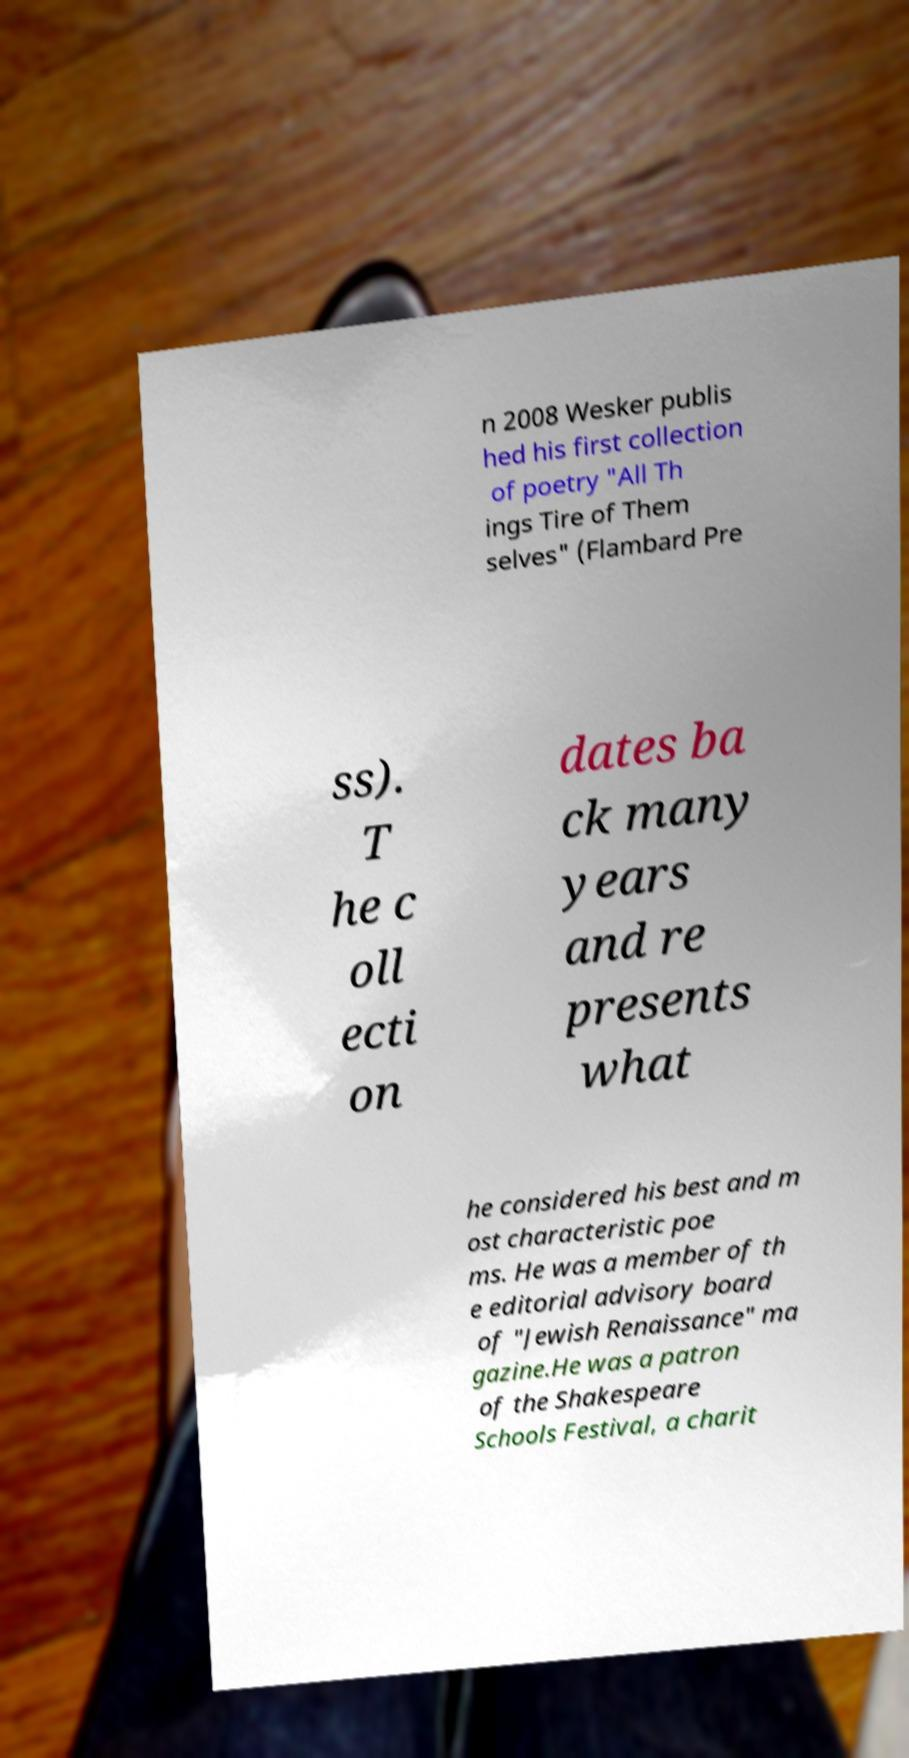I need the written content from this picture converted into text. Can you do that? n 2008 Wesker publis hed his first collection of poetry "All Th ings Tire of Them selves" (Flambard Pre ss). T he c oll ecti on dates ba ck many years and re presents what he considered his best and m ost characteristic poe ms. He was a member of th e editorial advisory board of "Jewish Renaissance" ma gazine.He was a patron of the Shakespeare Schools Festival, a charit 